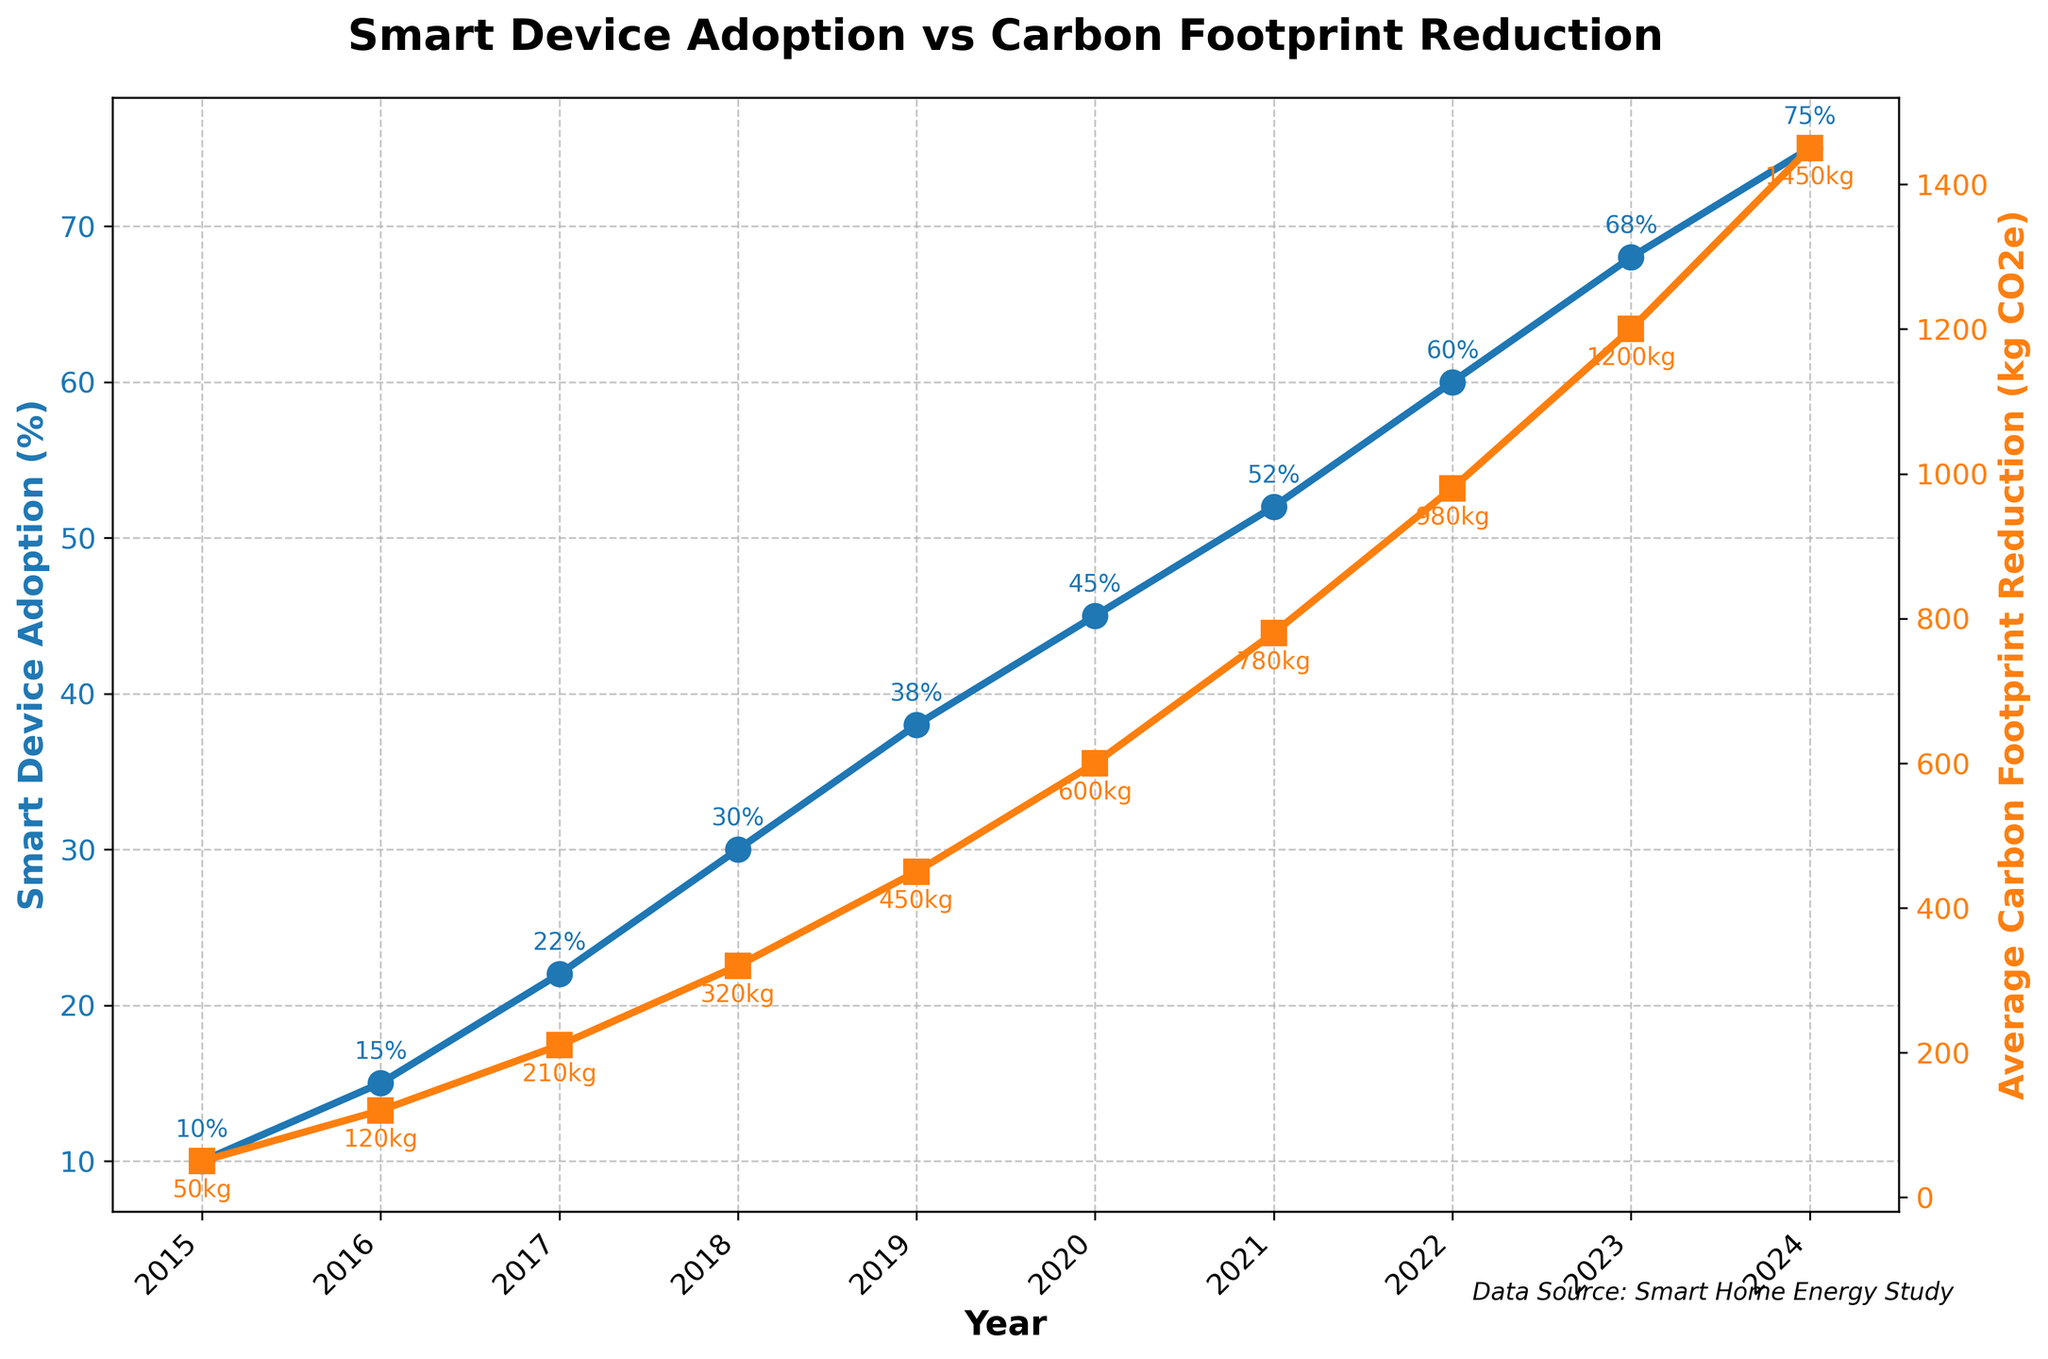What year had the highest Smart Device Adoption (%)? To find the highest Smart Device Adoption (%), we look at the green line and identify the year with the peak value. That is 2024 with a value of 75%.
Answer: 2024 By how much did the Average Carbon Footprint Reduction increase from 2016 to 2021? To find the increase, we subtract the 2016 value (120 kg CO2e) from the 2021 value (780 kg CO2e). Performing the calculation: 780 - 120 = 660 kg CO2e.
Answer: 660 kg CO2e Comparing 2018 and 2022, which year had a higher Smart Device Adoption (%) and by what margin? We look at both years: 2018 (30%) and 2022 (60%). To find the margin, we subtract the two values: 60% - 30% = 30%.
Answer: 2022, 30% Is there a year where both Smart Device Adoption (%) and Average Carbon Footprint Reduction increased significantly compared to the previous year? We examine the year-to-year increments in the plot. For instance, from 2019 to 2020, Smart Device Adoption (%) increased from 38% to 45%, and Average Carbon Footprint Reduction increased significantly from 450 kg CO2e to 600 kg CO2e. Both increases are notable.
Answer: 2020 What is the median Smart Device Adoption (%) value over the timeframe? To find the median value of the 10 values (10%, 15%, 22%, 30%, 38%, 45%, 52%, 60%, 68%, 75%), we take the average of the 5th and 6th values (38% and 45%): (38 + 45) / 2 = 41.5%.
Answer: 41.5% What's the average Annual Carbon Footprint Reduction from 2015 to 2024? Adding the values together: 50 + 120 + 210 + 320 + 450 + 600 + 780 + 980 + 1200 + 1450 = 6160 kg CO2e. There are 10 years, so the average is 6160 / 10 = 616 kg CO2e per year.
Answer: 616 kg CO2e How does the trend of Smart Device Adoption (%) compare visually to the trend of Average Carbon Footprint Reduction (kg CO2e)? Both trends show a positive increase over time. However, the rate of increase for Average Carbon Footprint Reduction appears steeper than the rate of increase for Smart Device Adoption (%), indicating a stronger impact on Carbon Footprint Reduction as Smart Device Adoption grows.
Answer: Both increasing, Carbon Footprint Reduction steeper In which year did the Average Carbon Footprint Reduction exceed 1000 kg CO2e? We look for the first year where the value exceeds 1000 kg CO2e. This happens in 2023, with a value of 1200 kg CO2e.
Answer: 2023 